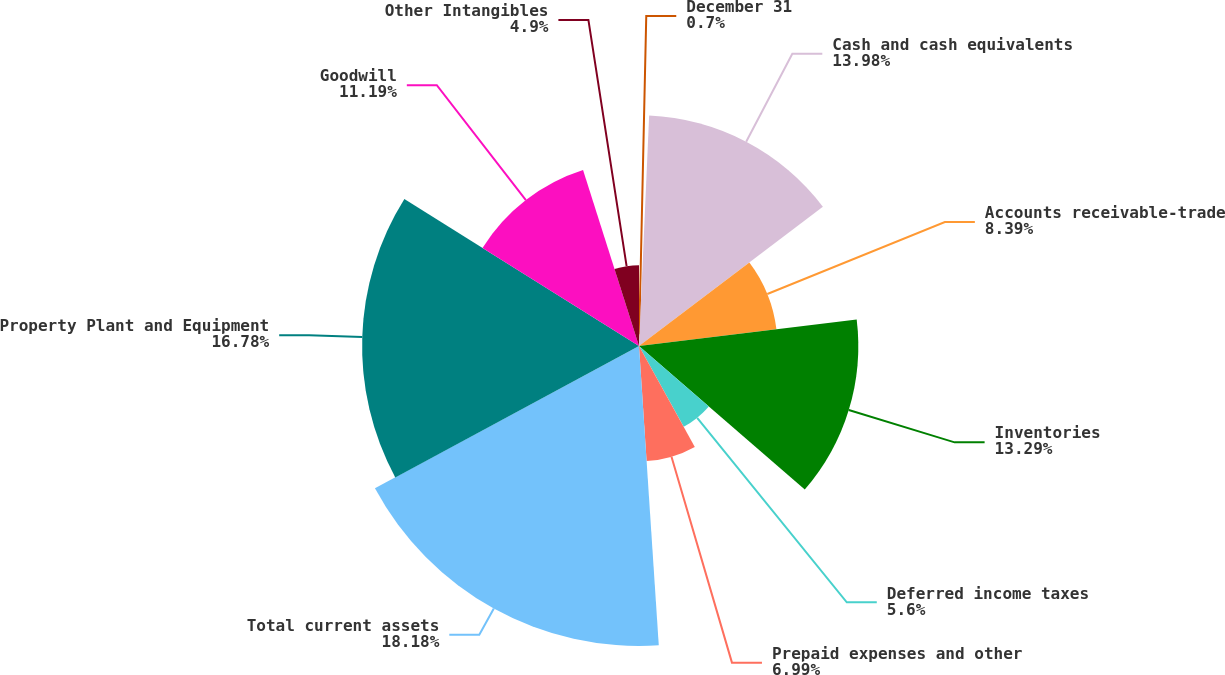Convert chart. <chart><loc_0><loc_0><loc_500><loc_500><pie_chart><fcel>December 31<fcel>Cash and cash equivalents<fcel>Accounts receivable-trade<fcel>Inventories<fcel>Deferred income taxes<fcel>Prepaid expenses and other<fcel>Total current assets<fcel>Property Plant and Equipment<fcel>Goodwill<fcel>Other Intangibles<nl><fcel>0.7%<fcel>13.98%<fcel>8.39%<fcel>13.29%<fcel>5.6%<fcel>6.99%<fcel>18.18%<fcel>16.78%<fcel>11.19%<fcel>4.9%<nl></chart> 